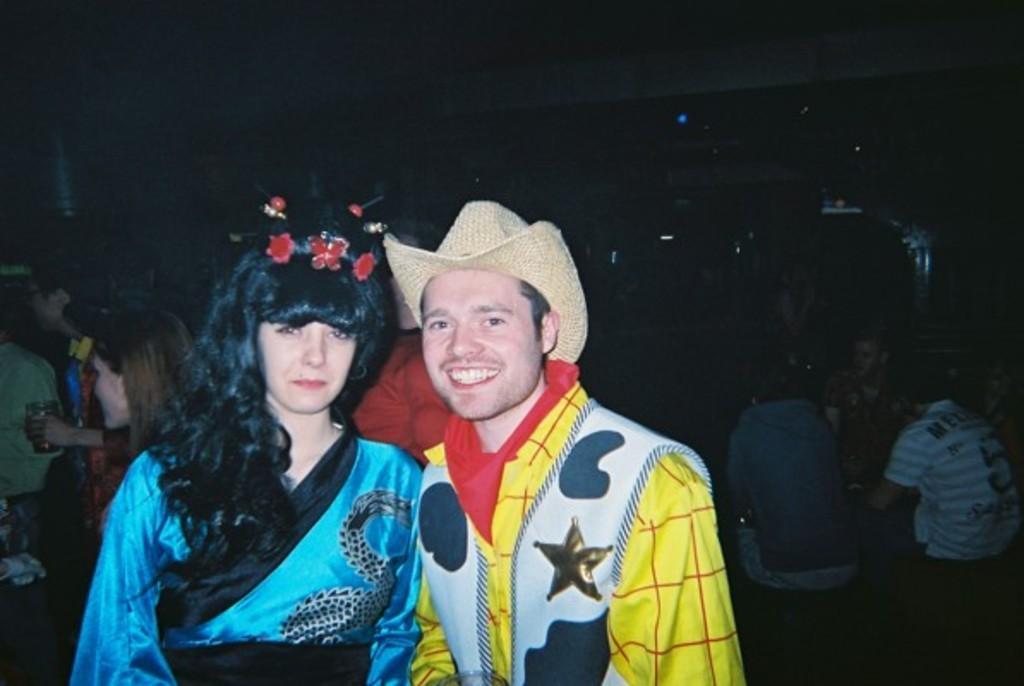In one or two sentences, can you explain what this image depicts? In front of the image there is a man and a woman with a smile on their face, behind them there are a few other people standing and sitting and some of them are holding glasses in their hands. 